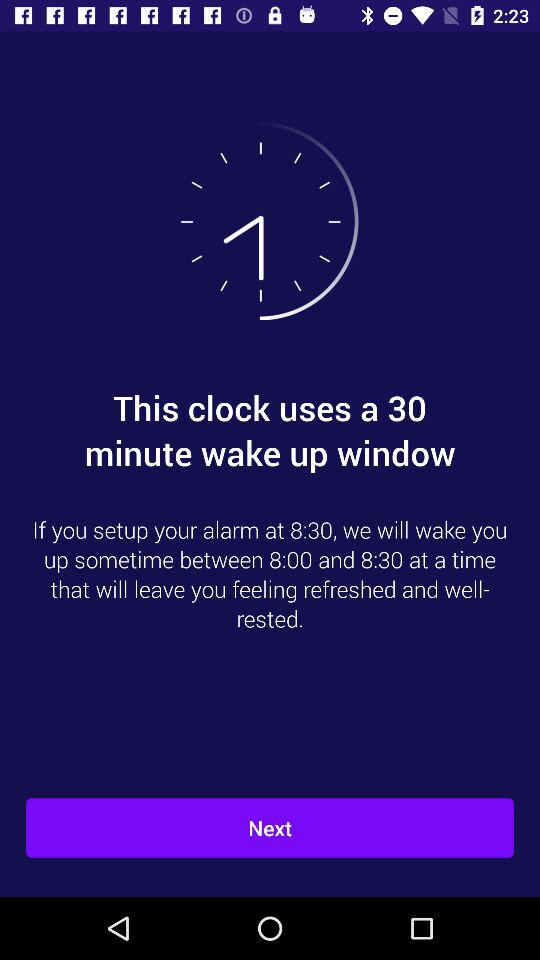This clock has a wake-up window of how many minutes? This clock has a wake-up window of 30 minutes. 